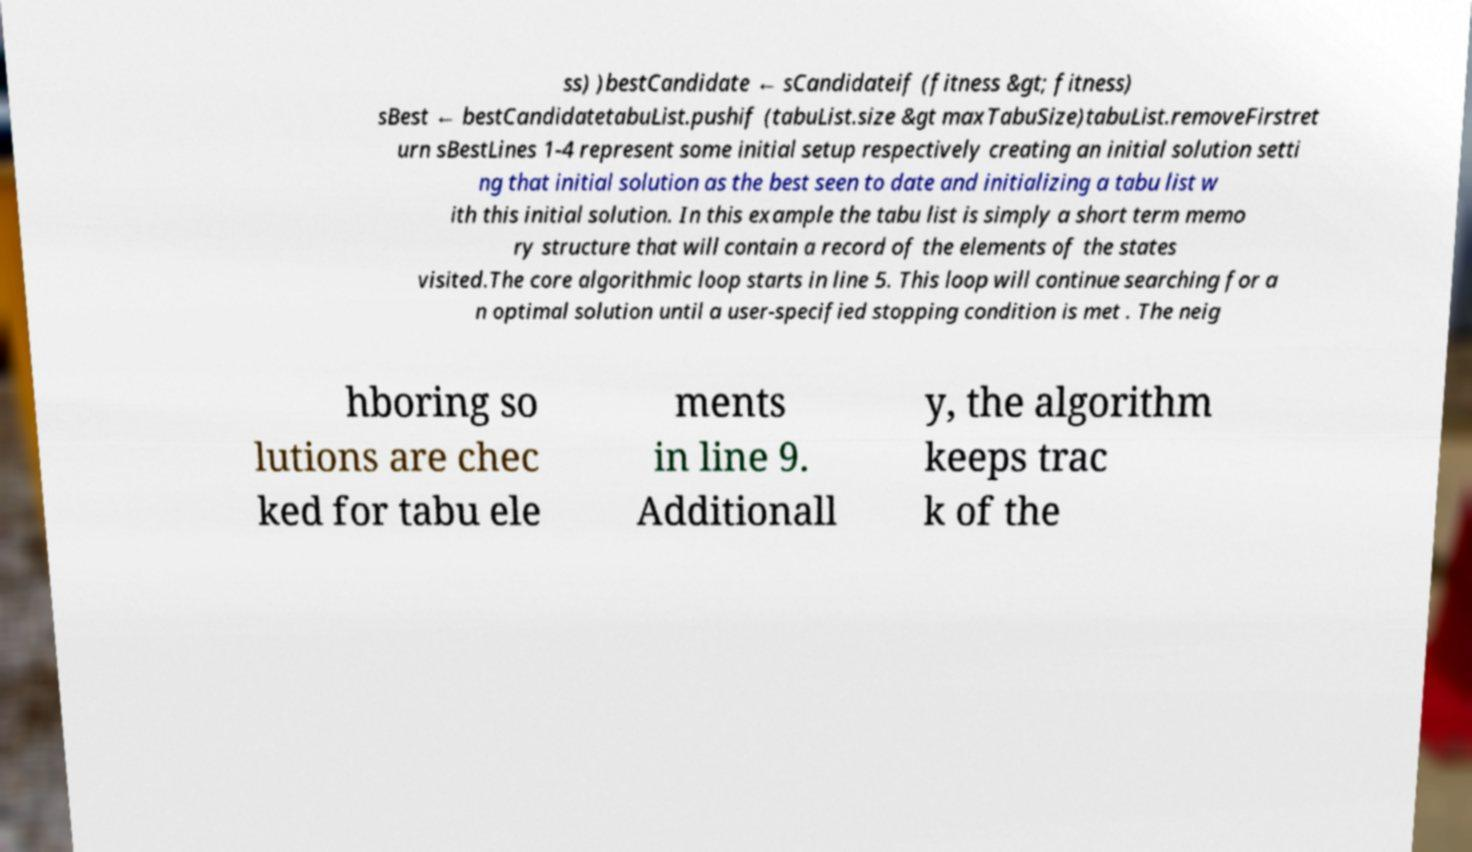Could you assist in decoding the text presented in this image and type it out clearly? ss) )bestCandidate ← sCandidateif (fitness &gt; fitness) sBest ← bestCandidatetabuList.pushif (tabuList.size &gt maxTabuSize)tabuList.removeFirstret urn sBestLines 1-4 represent some initial setup respectively creating an initial solution setti ng that initial solution as the best seen to date and initializing a tabu list w ith this initial solution. In this example the tabu list is simply a short term memo ry structure that will contain a record of the elements of the states visited.The core algorithmic loop starts in line 5. This loop will continue searching for a n optimal solution until a user-specified stopping condition is met . The neig hboring so lutions are chec ked for tabu ele ments in line 9. Additionall y, the algorithm keeps trac k of the 